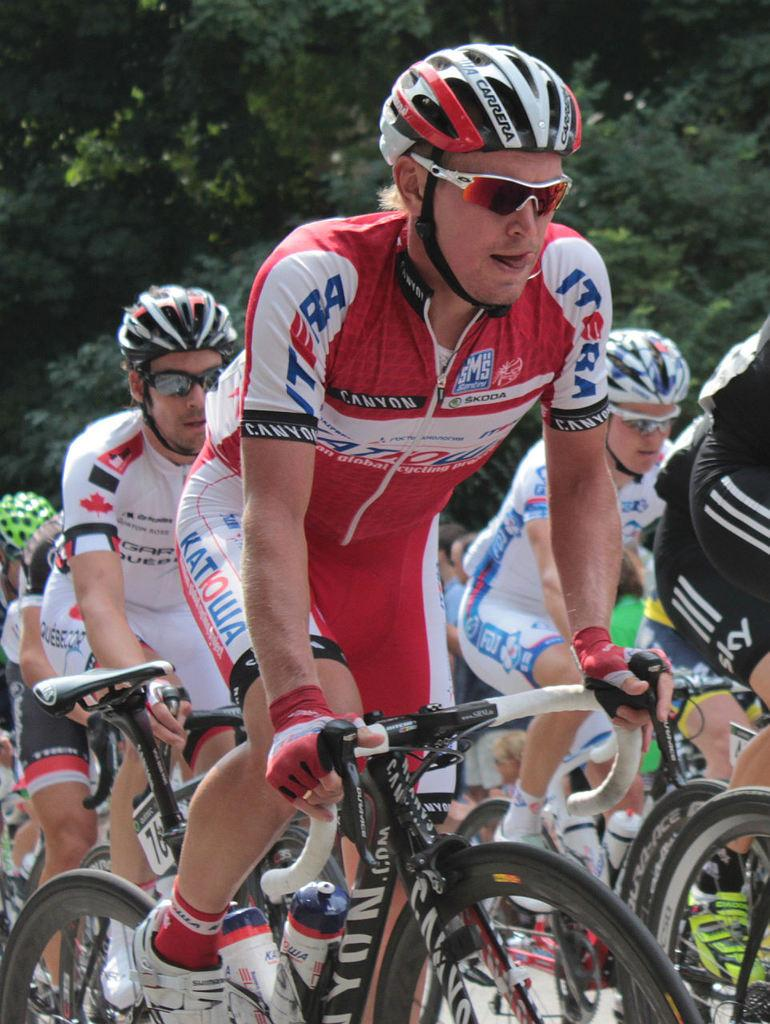What are the people in the image doing? The people in the image are riding bicycles. What safety precautions are the people taking while riding bicycles? The people are wearing helmets. Are there any other accessories the people are wearing in the image? Yes, the people are wearing spectacles. What can be seen in the background of the image? There are trees in the background of the image. What type of mint is growing on the hands of the people in the image? There is no mint growing on the hands of the people in the image. 